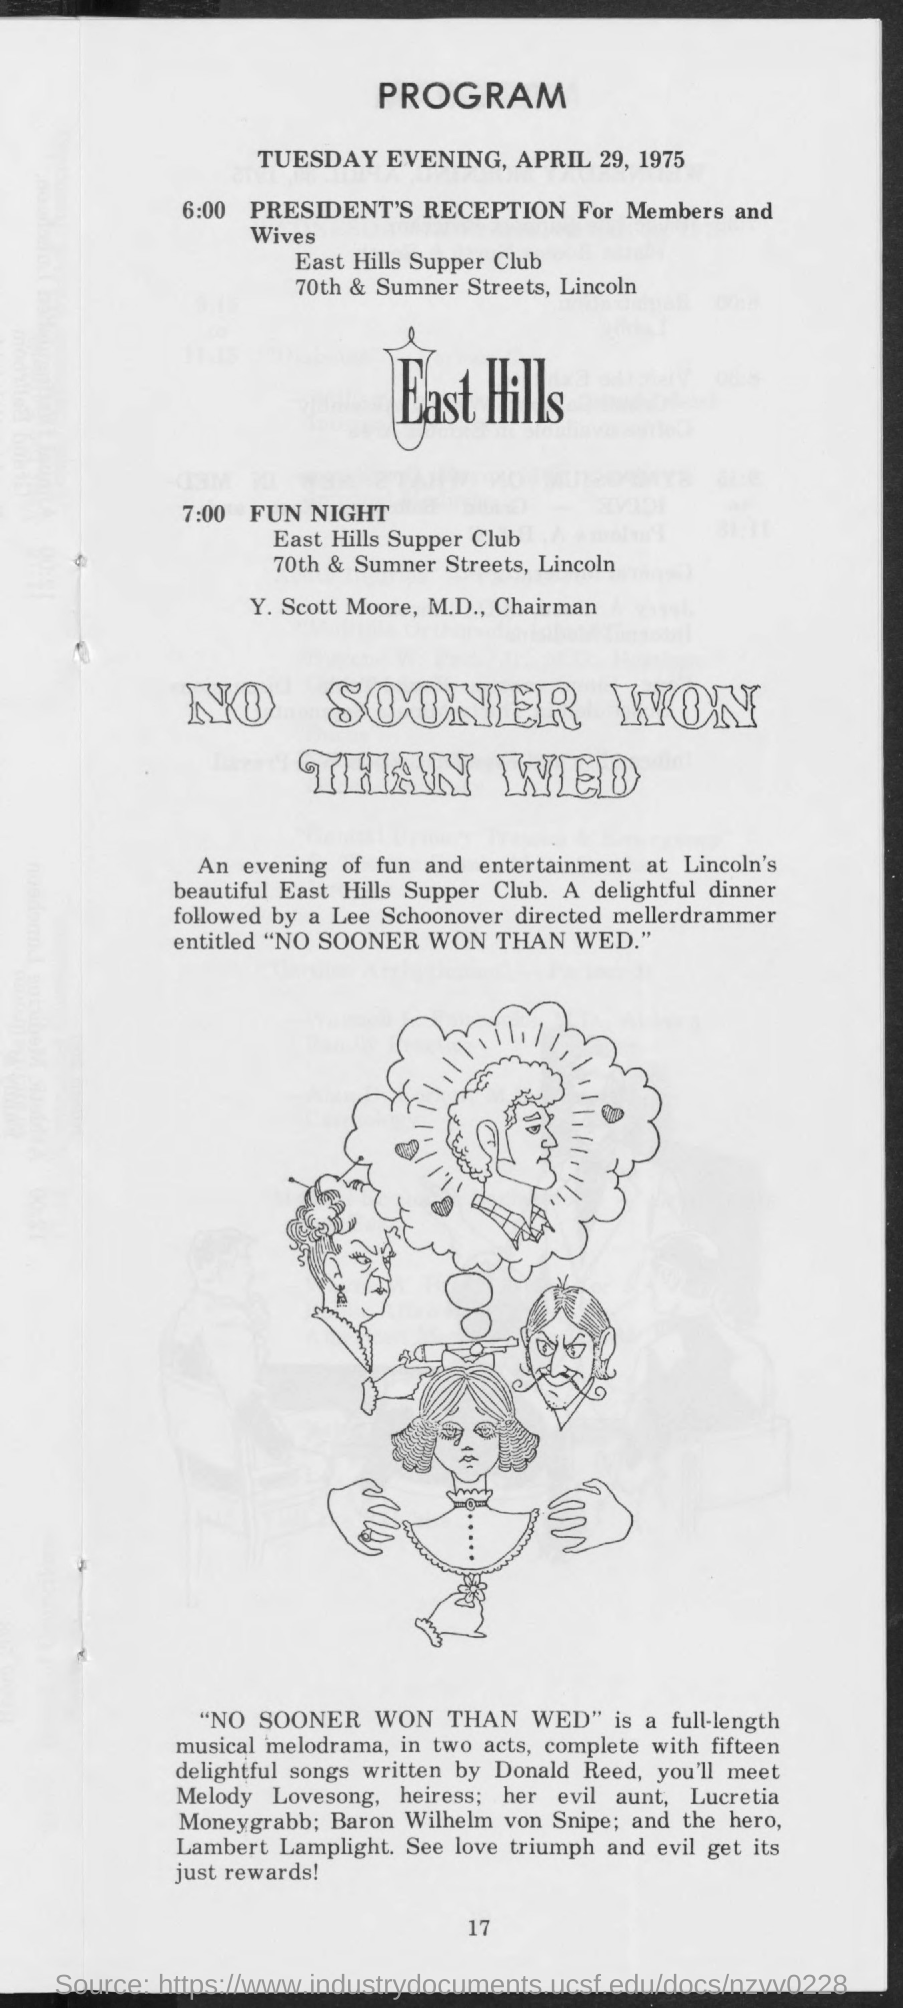When is the program going to be held?
Your answer should be compact. TUESDAY EVENING, APRIL 29, 1975. What is the event at 6:00?
Keep it short and to the point. President's reception for members and wives. Where is the FUN NIGHT scheduled to be?
Provide a short and direct response. East hills supper club. Who is the Chairman?
Your answer should be compact. Y. Scott Moore. What is the name of the mellerdrammer?
Your answer should be compact. No sooner won than wed. Who has directed the mellerdrammer?
Keep it short and to the point. Lee schoonover. Who has written the songs?
Your answer should be very brief. Donald Reed. 